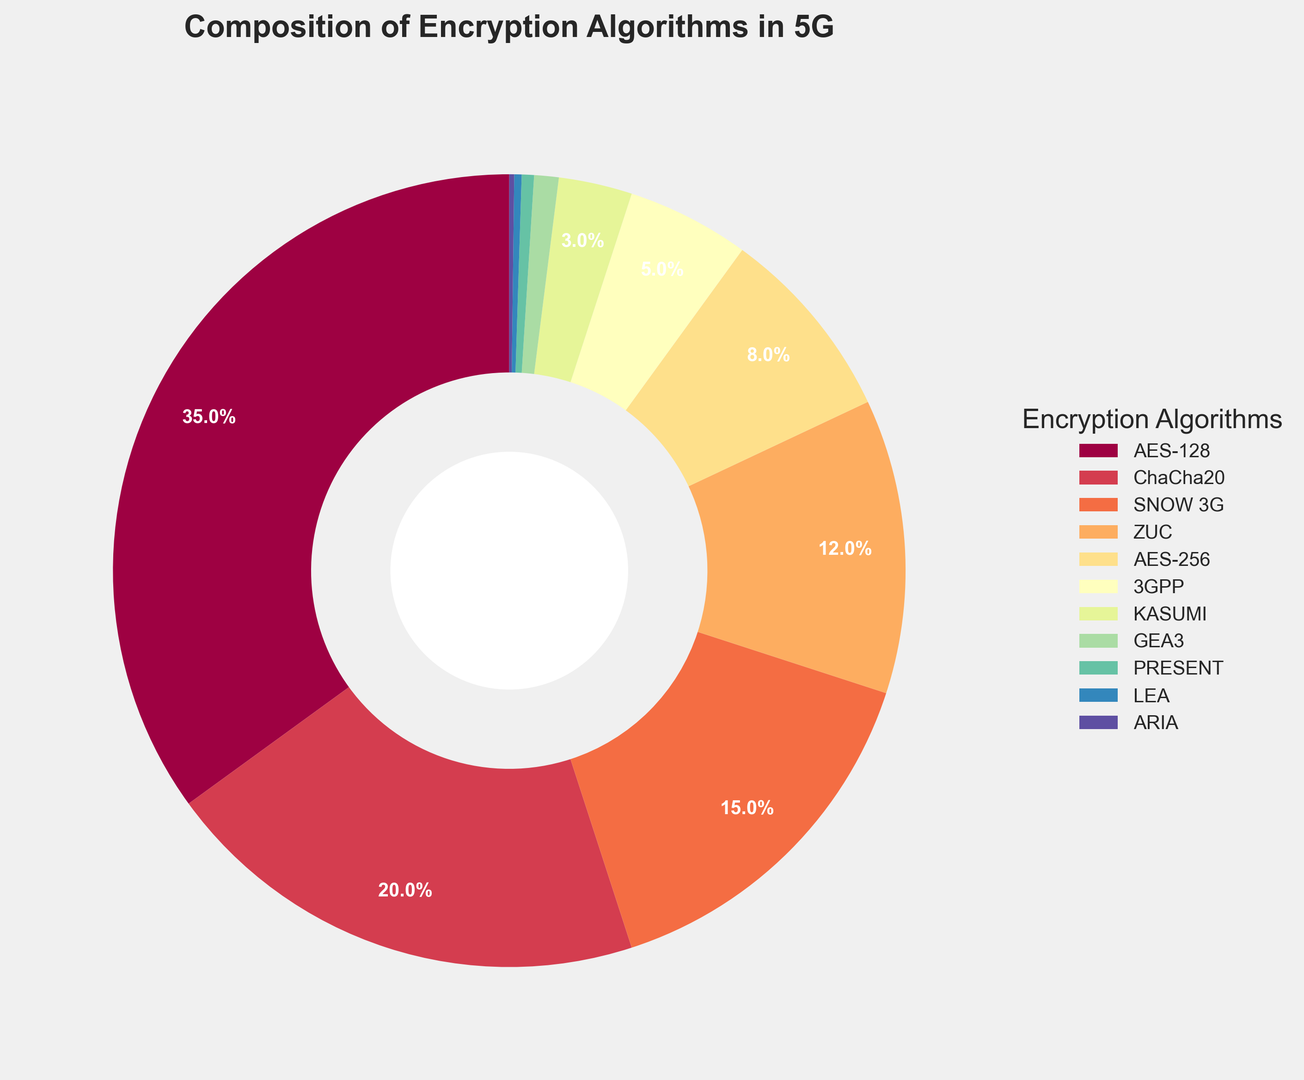What's the most commonly used encryption algorithm in 5G communication protocols? Look at the segment with the largest percentage. The chart shows that AES-128 has the largest portion at 35%.
Answer: AES-128 How does the usage percentage of ChaCha20 compare to that of AES-256? ChaCha20 occupies 20% while AES-256 takes up 8%. Comparison shows that ChaCha20 is more widely used than AES-256.
Answer: ChaCha20 is more widely used What is the combined percentage of SNOW 3G, ZUC, and 3GPP? Sum the percentages of SNOW 3G (15%), ZUC (12%), and 3GPP (5%). 15% + 12% + 5% = 32%.
Answer: 32% Which encryption algorithms have percentages less than 1%? Look at all segments and identify the ones with less than 1%. These are GEA3 (1%), PRESENT (0.5%), LEA (0.3%), and ARIA (0.2%).
Answer: GEA3, PRESENT, LEA, ARIA What is the percentage difference between AES-128 and SNOW 3G? Subtract SNOW 3G’s percentage (15%) from AES-128’s percentage (35%). 35% - 15% = 20%.
Answer: 20% Are there any encryption algorithms with usage of 12%? Check the segments for any displaying 12%. It shows that ZUC has 12%.
Answer: ZUC Which encryption algorithm is represented by the smallest segment? Identify the segment with the smallest percentage. ARIA has the smallest percentage at 0.2%.
Answer: ARIA How many encryption algorithms have a usage percentage greater than 10%? Count the segments where the usage percentage is more than 10%. They are AES-128 (35%), ChaCha20 (20%), SNOW 3G (15%), and ZUC (12%). Thus, there are 4 algorithms.
Answer: 4 What is the total percentage of the top two most used encryption algorithms? Sum the percentages of the top two (AES-128 and ChaCha20). 35% + 20% = 55%.
Answer: 55% Visually, what color is the wedge representing the KASUMI algorithm? Identify the color of the segment labeled KASUMI in the chart. It appears as an entry in the color legend as some shade (often a darker color).
Answer: Check the figure's color legend for visual confirmation 